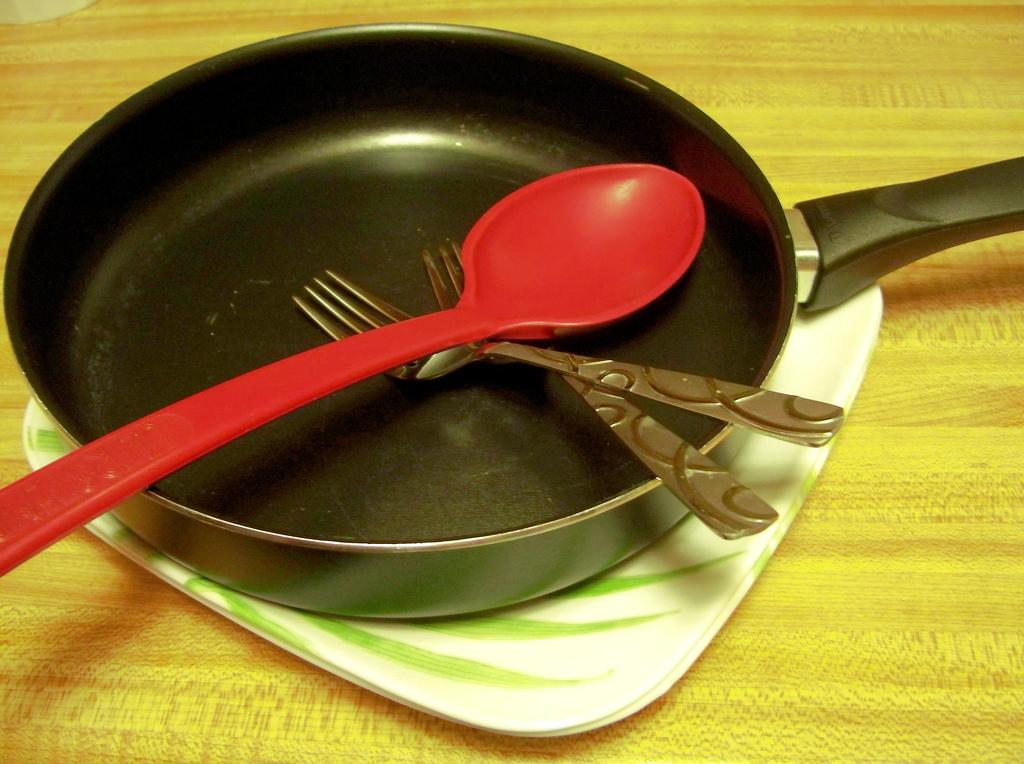What is the main kitchen utensil visible in the image? There is a frying pan in the image. What other utensil can be seen in the image? There is a spoon in the image. How many forks are present in the image? There are two forks in the image. Where are the utensils located in the image? The frying pan, spoon, and forks are placed on a table. What type of cactus is growing on the table in the image? There is no cactus present in the image; the utensils are placed on a table, but no plants are visible. 